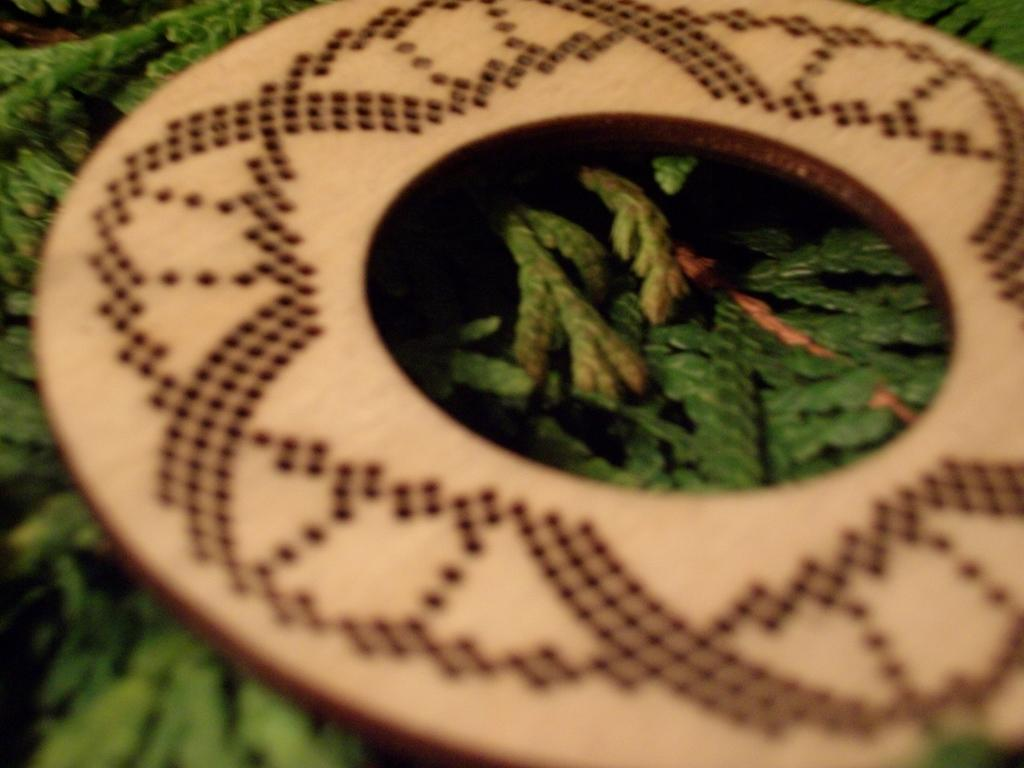What is the main object in the image? There is a wooden disk in the image. How is the wooden disk positioned in the image? The wooden disk is placed on some leaves. What songs can be heard being sung by the wooden disk in the image? The wooden disk does not sing songs in the image; it is an inanimate object. Is the wooden disk sinking into quicksand in the image? There is no quicksand present in the image, and therefore the wooden disk is not sinking into it. 